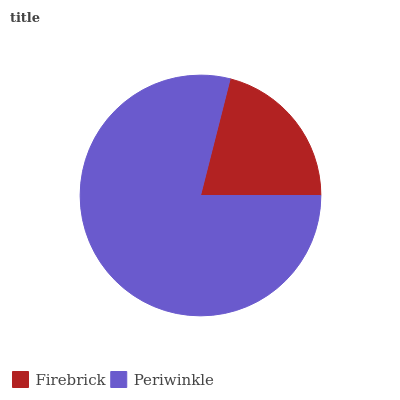Is Firebrick the minimum?
Answer yes or no. Yes. Is Periwinkle the maximum?
Answer yes or no. Yes. Is Periwinkle the minimum?
Answer yes or no. No. Is Periwinkle greater than Firebrick?
Answer yes or no. Yes. Is Firebrick less than Periwinkle?
Answer yes or no. Yes. Is Firebrick greater than Periwinkle?
Answer yes or no. No. Is Periwinkle less than Firebrick?
Answer yes or no. No. Is Periwinkle the high median?
Answer yes or no. Yes. Is Firebrick the low median?
Answer yes or no. Yes. Is Firebrick the high median?
Answer yes or no. No. Is Periwinkle the low median?
Answer yes or no. No. 